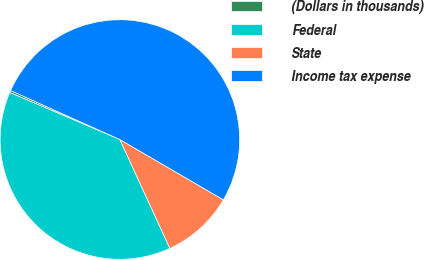Convert chart. <chart><loc_0><loc_0><loc_500><loc_500><pie_chart><fcel>(Dollars in thousands)<fcel>Federal<fcel>State<fcel>Income tax expense<nl><fcel>0.29%<fcel>38.27%<fcel>9.75%<fcel>51.68%<nl></chart> 